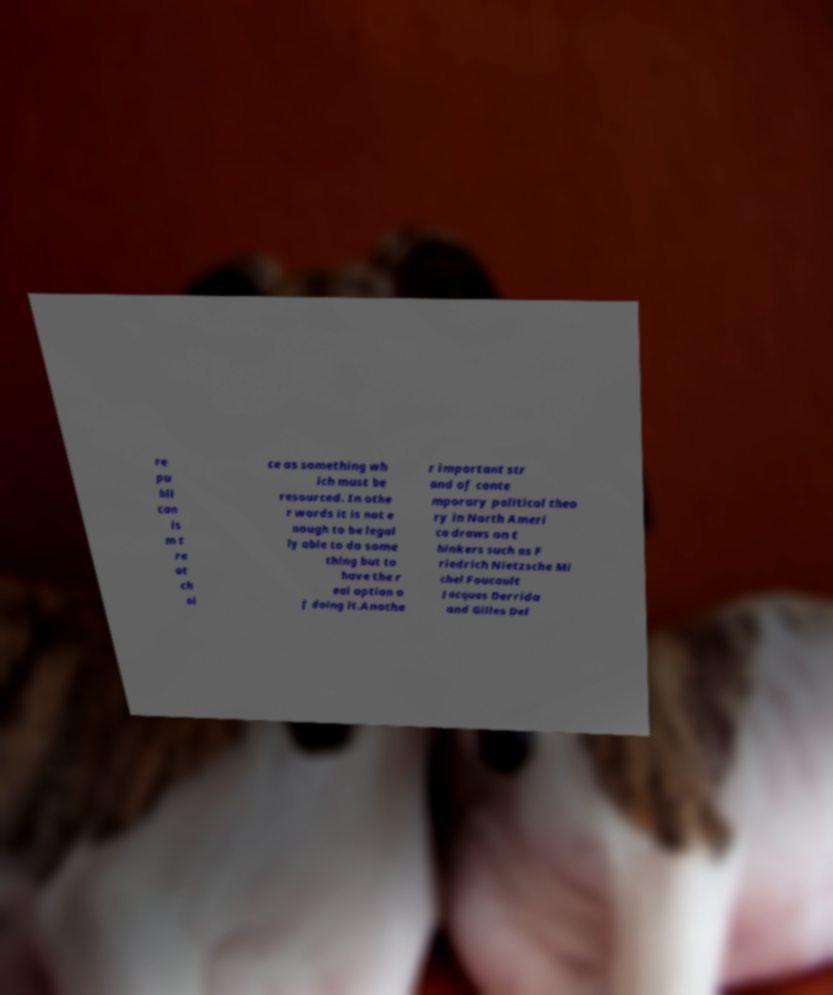I need the written content from this picture converted into text. Can you do that? re pu bli can is m t re at ch oi ce as something wh ich must be resourced. In othe r words it is not e nough to be legal ly able to do some thing but to have the r eal option o f doing it.Anothe r important str and of conte mporary political theo ry in North Ameri ca draws on t hinkers such as F riedrich Nietzsche Mi chel Foucault Jacques Derrida and Gilles Del 